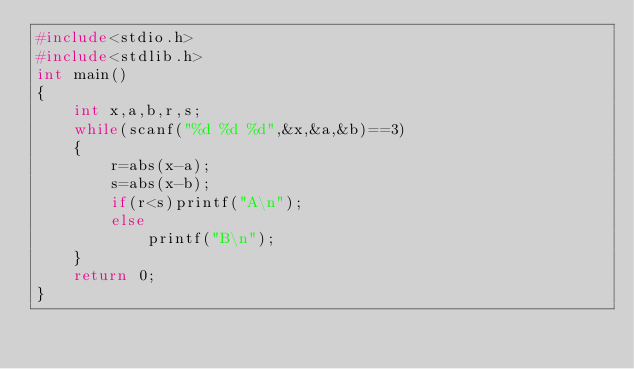Convert code to text. <code><loc_0><loc_0><loc_500><loc_500><_C_>#include<stdio.h>
#include<stdlib.h>
int main()
{
    int x,a,b,r,s;
    while(scanf("%d %d %d",&x,&a,&b)==3)
    {
        r=abs(x-a);
        s=abs(x-b);
        if(r<s)printf("A\n");
        else
            printf("B\n");
    }
    return 0;
}
</code> 